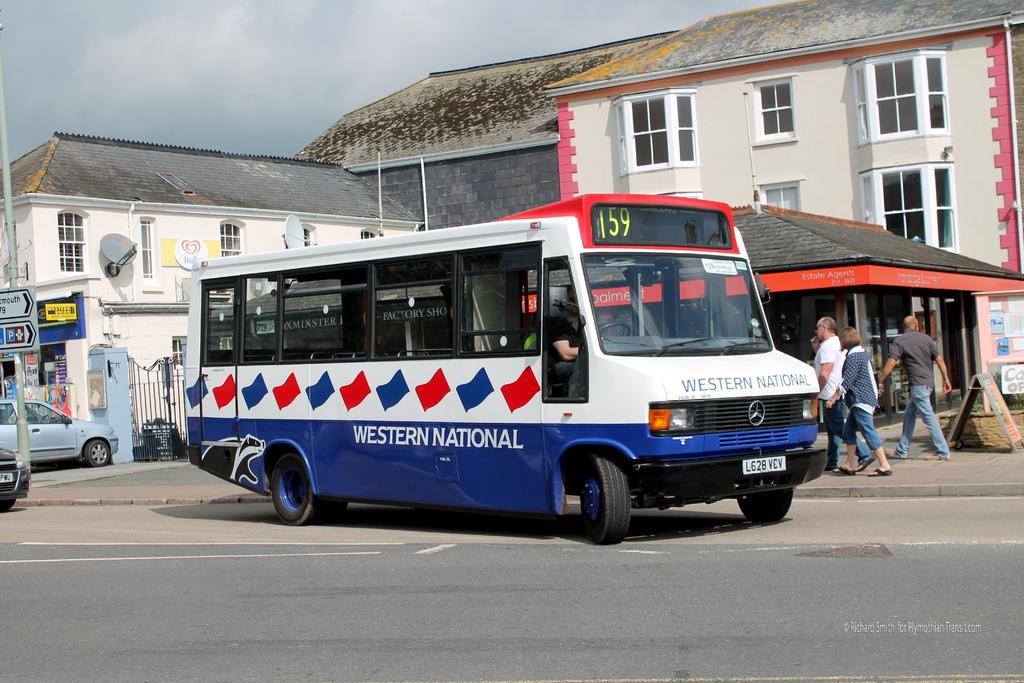What vehicle is this?
Offer a terse response. Western national. 